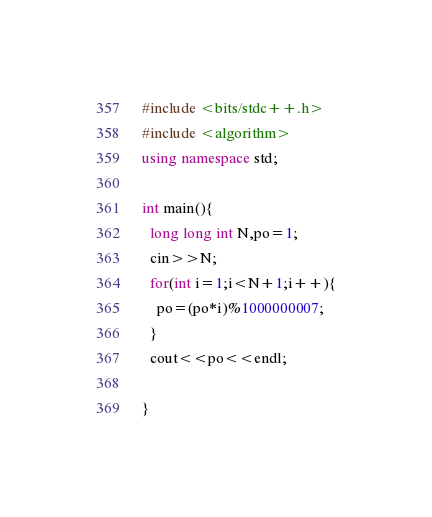<code> <loc_0><loc_0><loc_500><loc_500><_C++_>#include <bits/stdc++.h>
#include <algorithm>
using namespace std;

int main(){
  long long int N,po=1;
  cin>>N;
  for(int i=1;i<N+1;i++){
    po=(po*i)%1000000007;
  }
  cout<<po<<endl;
  
}</code> 